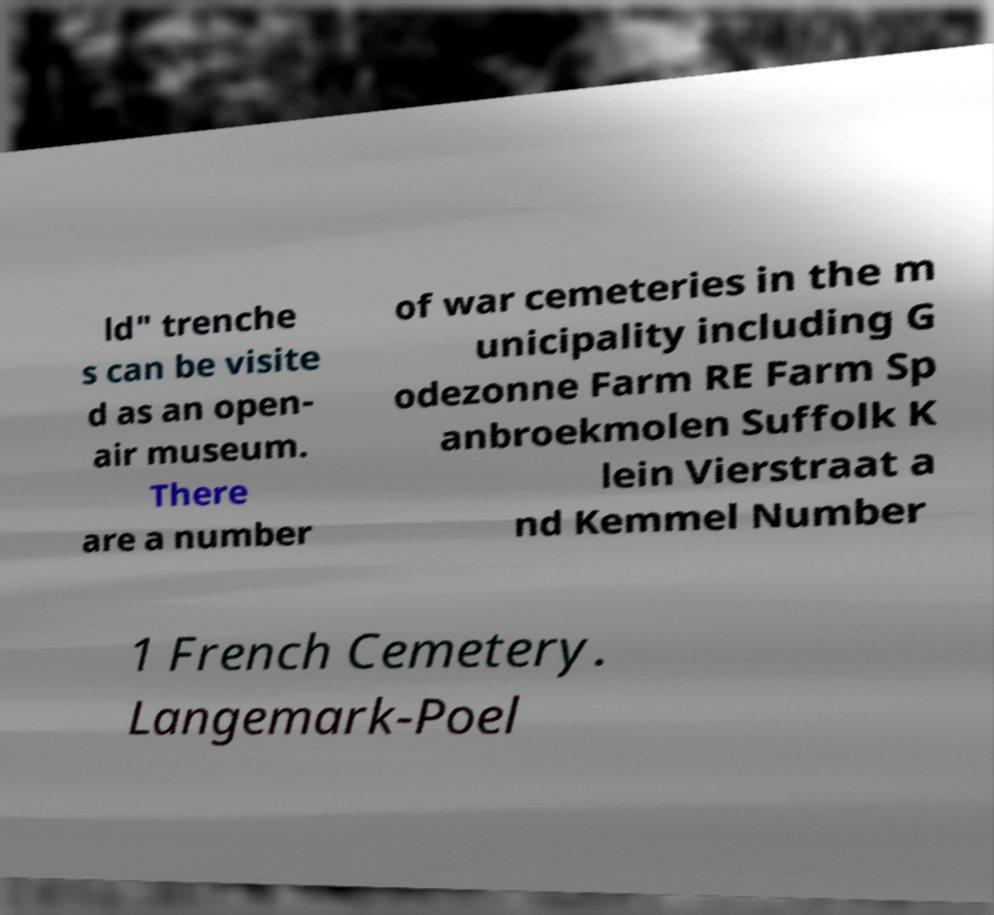What messages or text are displayed in this image? I need them in a readable, typed format. ld" trenche s can be visite d as an open- air museum. There are a number of war cemeteries in the m unicipality including G odezonne Farm RE Farm Sp anbroekmolen Suffolk K lein Vierstraat a nd Kemmel Number 1 French Cemetery. Langemark-Poel 